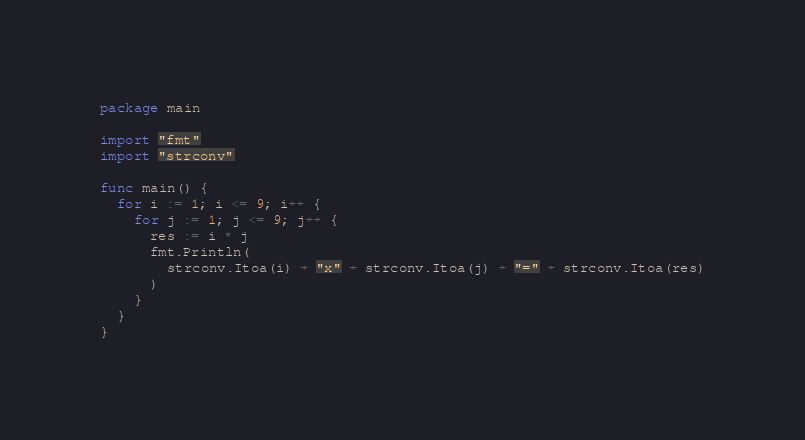Convert code to text. <code><loc_0><loc_0><loc_500><loc_500><_Go_>package main

import "fmt"
import "strconv"

func main() {
  for i := 1; i <= 9; i++ {
    for j := 1; j <= 9; j++ {
      res := i * j
      fmt.Println(
        strconv.Itoa(i) + "x" + strconv.Itoa(j) + "=" + strconv.Itoa(res)
      )
    }
  }
}

</code> 